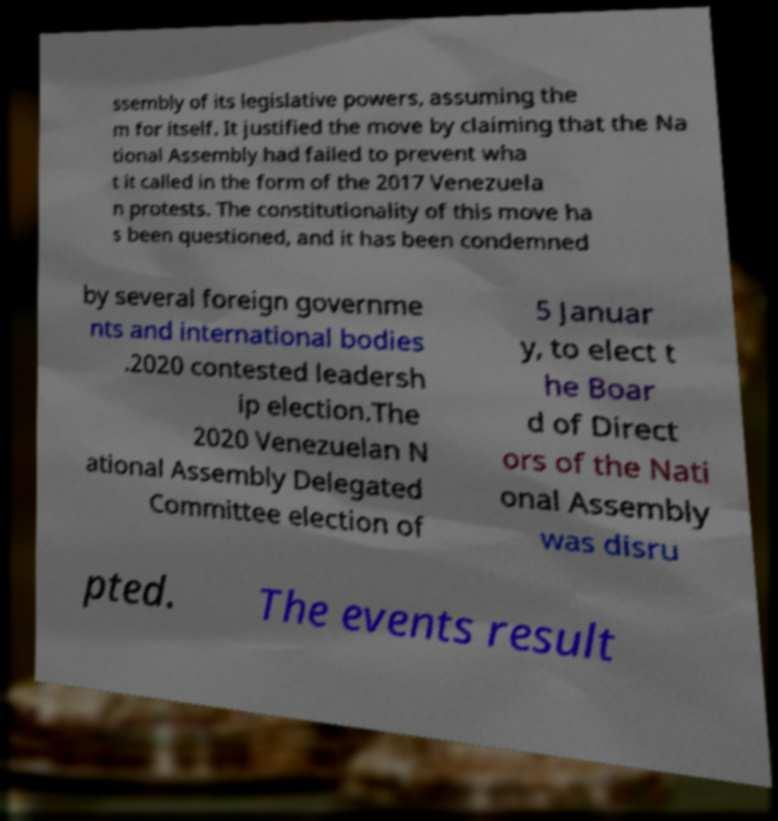For documentation purposes, I need the text within this image transcribed. Could you provide that? ssembly of its legislative powers, assuming the m for itself. It justified the move by claiming that the Na tional Assembly had failed to prevent wha t it called in the form of the 2017 Venezuela n protests. The constitutionality of this move ha s been questioned, and it has been condemned by several foreign governme nts and international bodies .2020 contested leadersh ip election.The 2020 Venezuelan N ational Assembly Delegated Committee election of 5 Januar y, to elect t he Boar d of Direct ors of the Nati onal Assembly was disru pted. The events result 